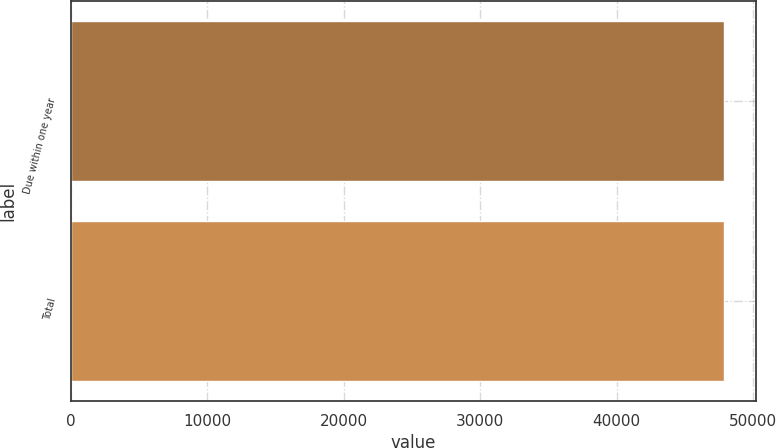<chart> <loc_0><loc_0><loc_500><loc_500><bar_chart><fcel>Due within one year<fcel>Total<nl><fcel>47856<fcel>47856.1<nl></chart> 